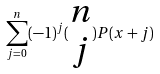Convert formula to latex. <formula><loc_0><loc_0><loc_500><loc_500>\sum _ { j = 0 } ^ { n } ( - 1 ) ^ { j } ( \begin{matrix} n \\ j \end{matrix} ) P ( x + j )</formula> 